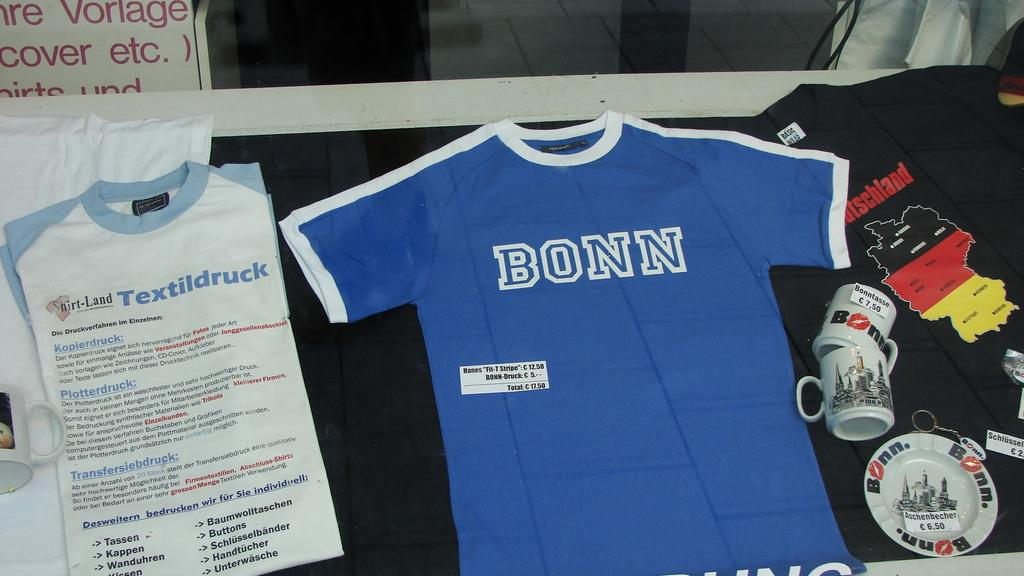<image>
Create a compact narrative representing the image presented. A number of t-shirts are displayed, including one for Bonn and a black Deutschland shirt. 